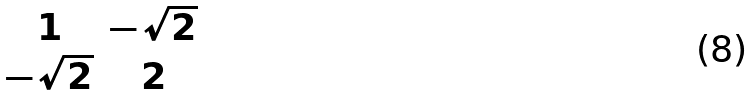Convert formula to latex. <formula><loc_0><loc_0><loc_500><loc_500>\begin{matrix} 1 & - \sqrt { 2 } \\ - \sqrt { 2 } & 2 \end{matrix}</formula> 